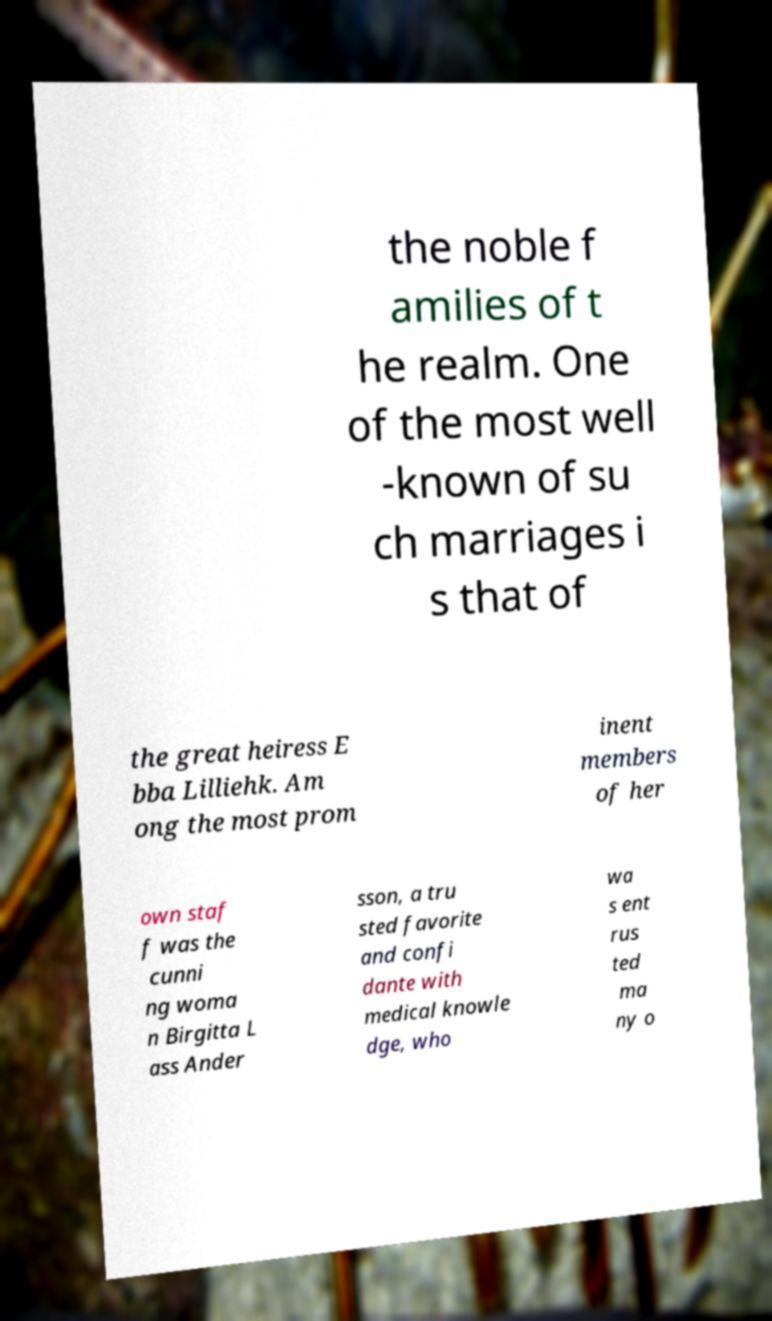Please read and relay the text visible in this image. What does it say? the noble f amilies of t he realm. One of the most well -known of su ch marriages i s that of the great heiress E bba Lilliehk. Am ong the most prom inent members of her own staf f was the cunni ng woma n Birgitta L ass Ander sson, a tru sted favorite and confi dante with medical knowle dge, who wa s ent rus ted ma ny o 